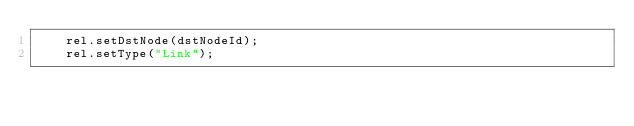Convert code to text. <code><loc_0><loc_0><loc_500><loc_500><_Java_>		rel.setDstNode(dstNodeId);
		rel.setType("Link");</code> 